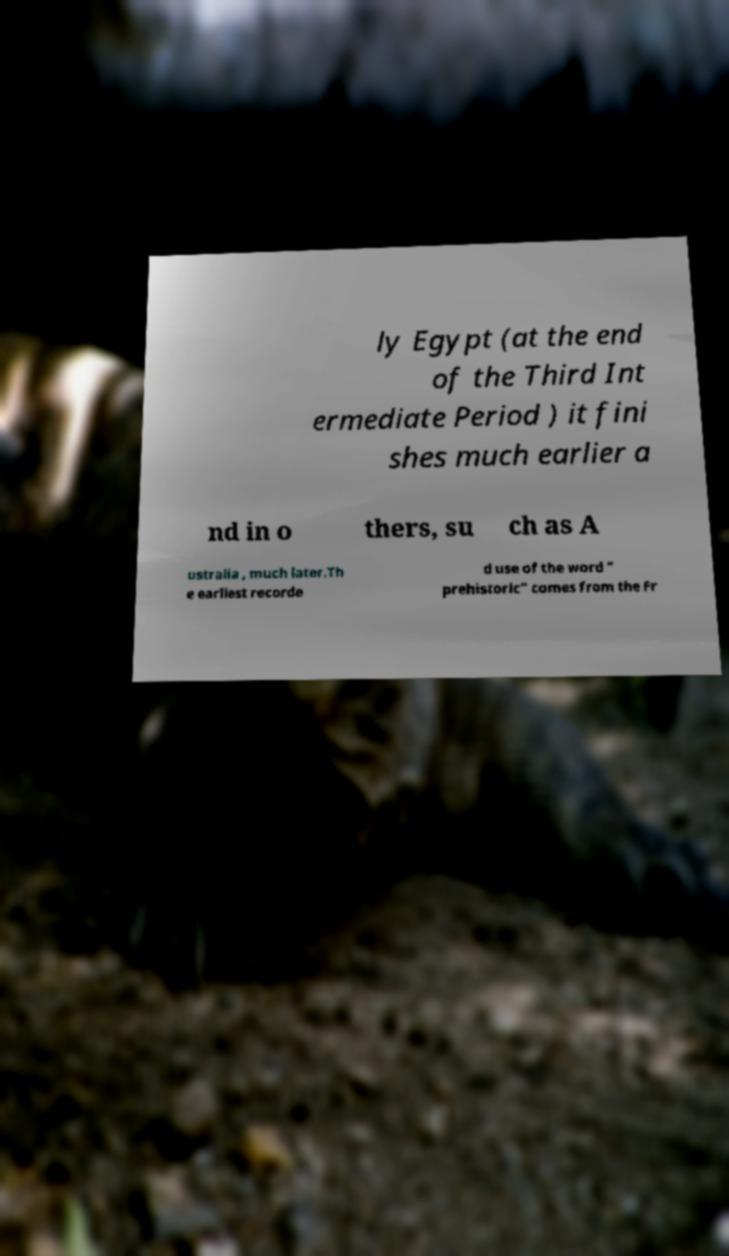Please identify and transcribe the text found in this image. ly Egypt (at the end of the Third Int ermediate Period ) it fini shes much earlier a nd in o thers, su ch as A ustralia , much later.Th e earliest recorde d use of the word " prehistoric" comes from the Fr 